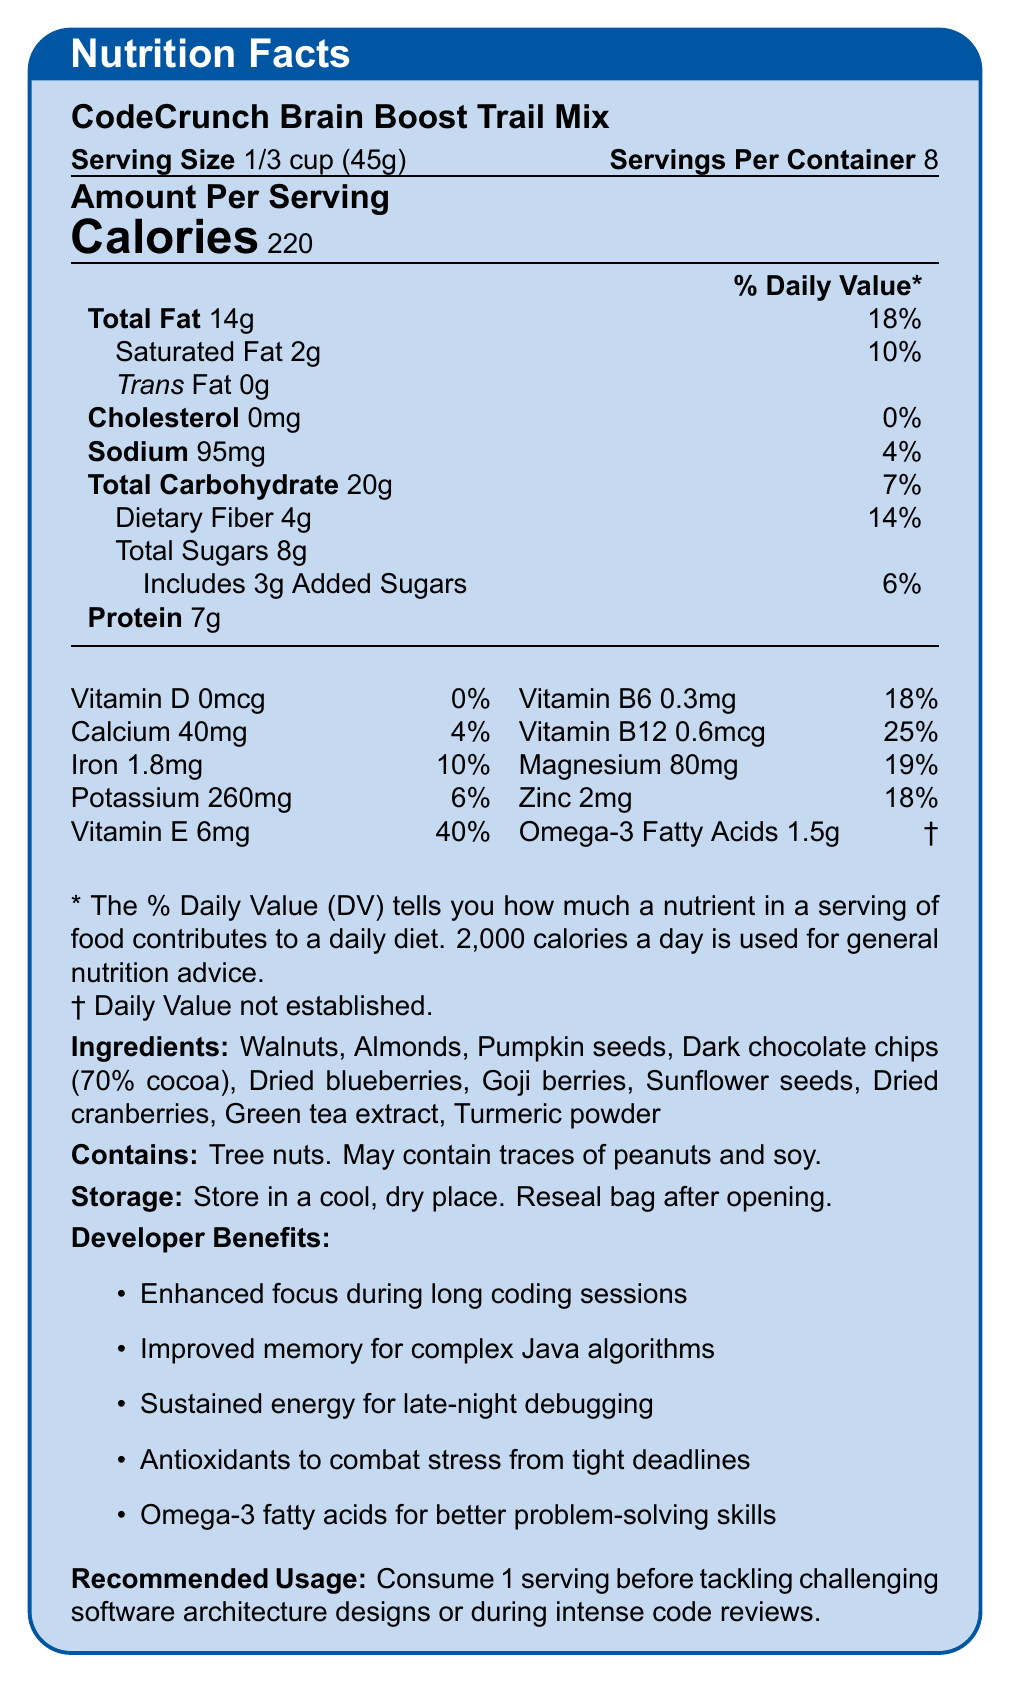What is the serving size of CodeCrunch Brain Boost Trail Mix? The document states that the serving size of CodeCrunch Brain Boost Trail Mix is 1/3 cup (45g).
Answer: 1/3 cup (45g) How many servings are in one container? According to the document, there are 8 servings per container.
Answer: 8 What is the protein content per serving? The document specifies that each serving contains 7g of protein.
Answer: 7g Which nutrient has the highest daily value percentage per serving? The nutrient with the highest daily value percentage per serving is Vitamin E at 40%.
Answer: Vitamin E List three main ingredients in the trail mix. The main ingredients listed in the document include Walnuts, Almonds, and Pumpkin seeds.
Answer: Walnuts, Almonds, Pumpkin seeds What is the calorie content per serving? A. 100 B. 150 C. 220 D. 300 The document indicates that there are 220 calories per serving.
Answer: C Which of the following ingredients is not found in the trail mix? A. Walnuts B. Almonds C. Dried strawberries D. Goji berries The ingredients listed are Walnuts, Almonds, Pumpkin seeds, Dark chocolate chips, Dried blueberries, Goji berries, Sunflower seeds, Dried cranberries, Green tea extract, and Turmeric powder. Dried strawberries are not included.
Answer: C Does this product contain any trans fat? The document mentions that the amount of trans fat per serving is 0g, indicating that it contains no trans fat.
Answer: No Can someone with a peanut allergy safely consume this product? The document states that the product contains tree nuts and may contain traces of peanuts, so it is not safe for someone with a peanut allergy.
Answer: No Summarize the document with the main details and benefits. The summary includes the main details such as the nutrition facts, key ingredients, developer benefits, usage recommendations, and allergen information to give a comprehensive understanding of the document.
Answer: The document provides detailed nutrition facts and key ingredients for CodeCrunch Brain Boost Trail Mix, designed to enhance cognitive function, especially beneficial for developers undergoing complex problem-solving. It lists serving size, calories, fat content, and other nutrients, along with percentages of daily values. The document also highlights the specific developer benefits of the trail mix and gives usage recommendations and allergen information. How many grams of added sugars are in one serving? The document specifies that there are 3 grams of added sugars per serving.
Answer: 3g What is the 'daily value' percentage of magnesium per serving? The document states that the daily value percentage of magnesium per serving is 19%.
Answer: 19% How should the trail mix be stored after opening? The document advises storing the trail mix in a cool, dry place and resealing the bag after opening to maintain freshness.
Answer: In a cool, dry place, and reseal the bag What is the primary purpose of consuming this trail mix for developers? The document outlines benefits like enhanced focus, improved memory, and sustained energy as the primary purposes for consuming this trail mix for developers.
Answer: To enhance focus, memory, and sustain energy during coding sessions Does the product contain soy? The document mentions that the product may contain traces of soy, which means it could potentially contain soy but is not a primary ingredient.
Answer: It may contain traces What percentage of daily iron does one serving provide? The document states that one serving provides 10% of the daily value for iron.
Answer: 10% What kind of extract is included as an ingredient in the trail mix? The document lists Green tea extract as one of the ingredients.
Answer: Green tea extract What is the dietary fiber content in one serving? The document indicates that there are 4 grams of dietary fiber per serving.
Answer: 4g Is the vitamin D content significant in this trail mix? The document shows that the vitamin D content per serving is 0mcg, which is 0% of the daily value, indicating it is not significant.
Answer: No How many milligrams of calcium are present in each serving? The document specifies that there are 40mg of calcium per serving.
Answer: 40mg What unique ingredient is included that could offer additional health benefits? The document lists Turmeric powder as an ingredient, which is known for its anti-inflammatory and antioxidant properties.
Answer: Turmeric powder Why does the trail mix have potential benefits for late-night debugging sessions? The document mentions that one of the developer benefits is sustained energy for late-night debugging sessions.
Answer: Because it provides sustained energy 